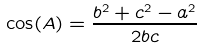Convert formula to latex. <formula><loc_0><loc_0><loc_500><loc_500>\cos ( A ) = { \frac { b ^ { 2 } + c ^ { 2 } - a ^ { 2 } } { 2 b c } }</formula> 